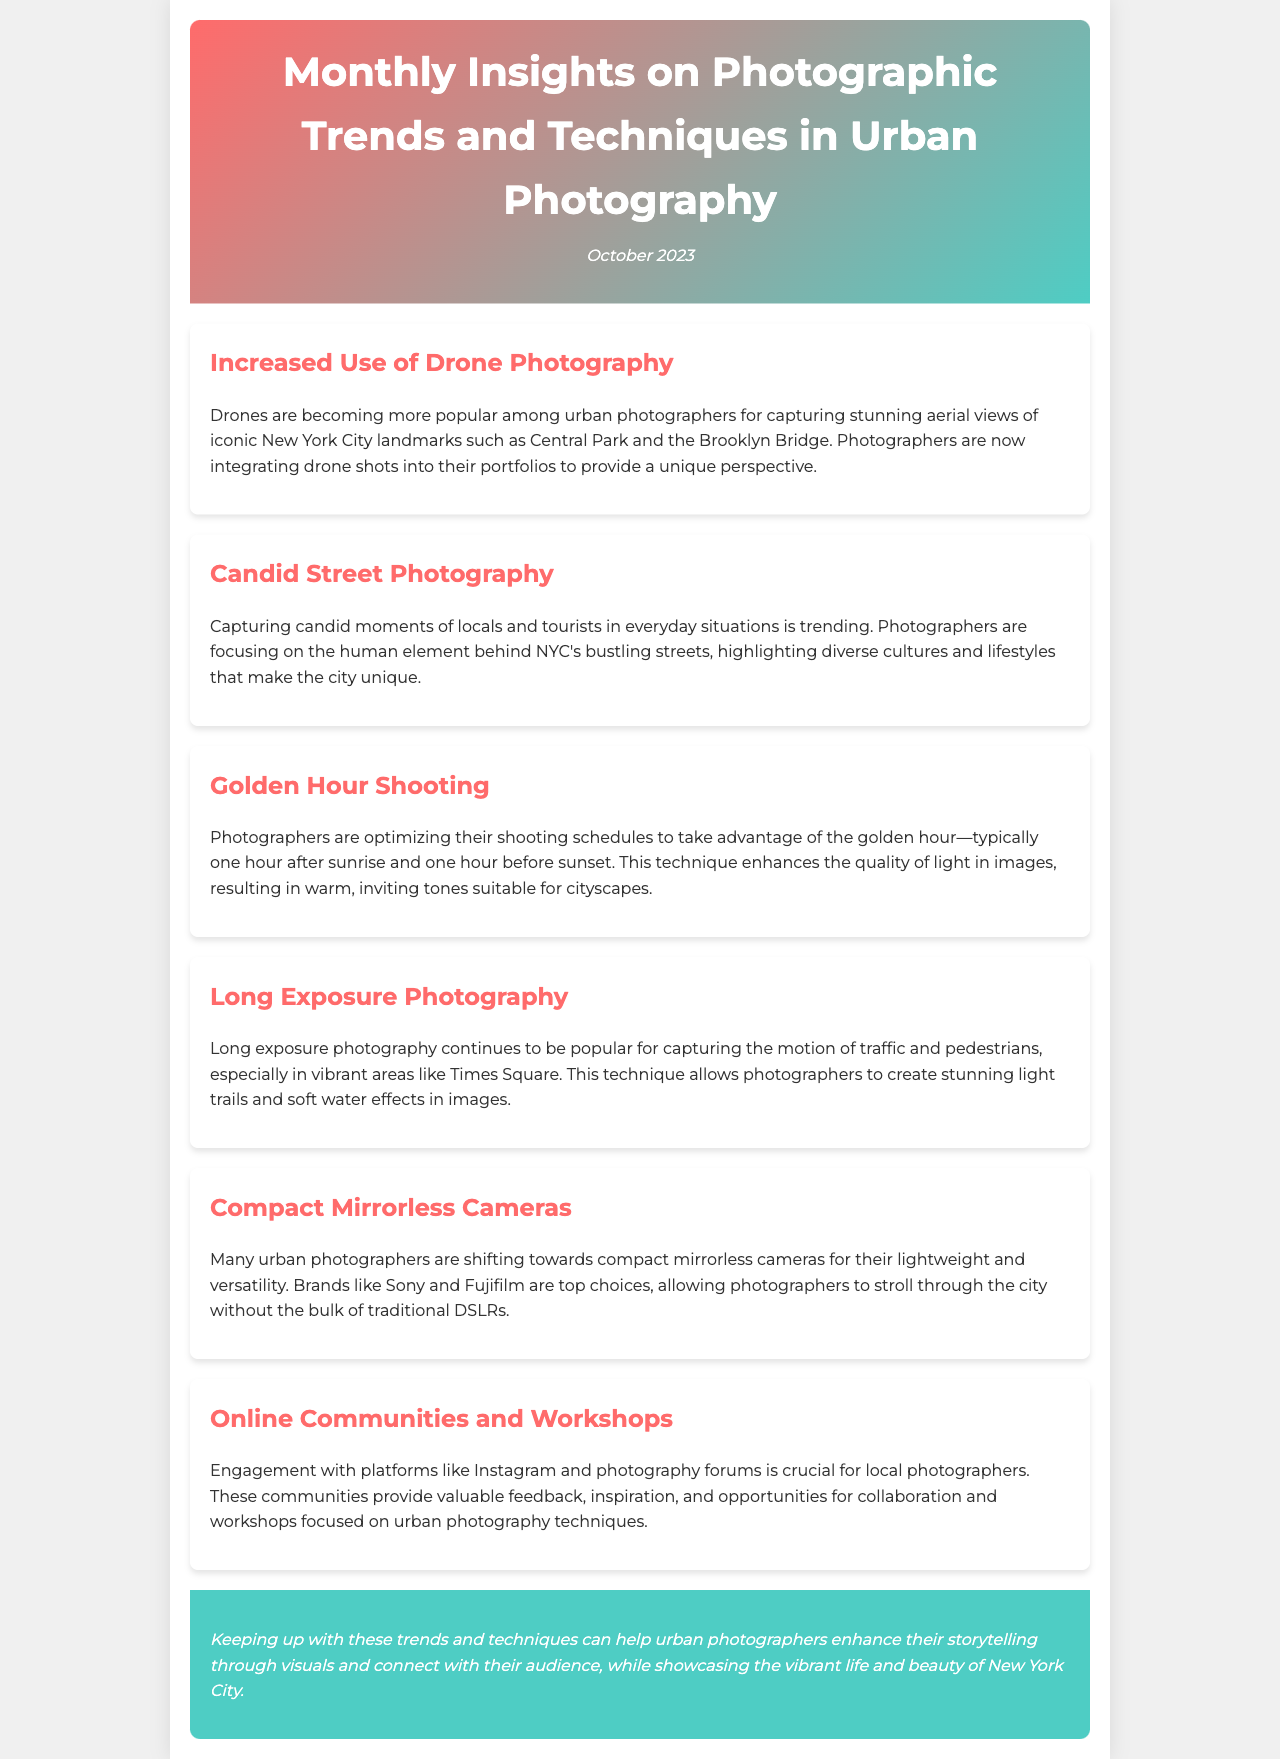What is the report title? The title of the report is presented at the top of the document.
Answer: Monthly Insights on Photographic Trends and Techniques in Urban Photography What month and year does the report cover? The report includes a date indicating the month and year it is published.
Answer: October 2023 Which technique is becoming popular for capturing aerial views? The document discusses an increasing trend in a specific photographic technique.
Answer: Drone Photography What is a key element being captured in candid street photography? The description of the candid street photography trend highlights a specific focus in the images.
Answer: Locals and tourists What time of day do photographers optimize their schedules for golden hour shooting? The report defines a specific time frame that photographers favor for shooting.
Answer: One hour after sunrise and one hour before sunset Which type of cameras are urban photographers shifting towards? The report mentions a shift in camera preferences among urban photographers.
Answer: Compact mirrorless cameras What is the primary advantage of using compact mirrorless cameras? The document highlights a specific benefit of the mentioned camera type.
Answer: Lightweight and versatility What platforms are important for local photographers to engage with? The insights section reveals key platforms used by photographers for community engagement.
Answer: Instagram and photography forums How does long exposure photography enhance urban scenes? The document describes the effect that long exposure photography has on urban imagery.
Answer: Capturing the motion of traffic and pedestrians 